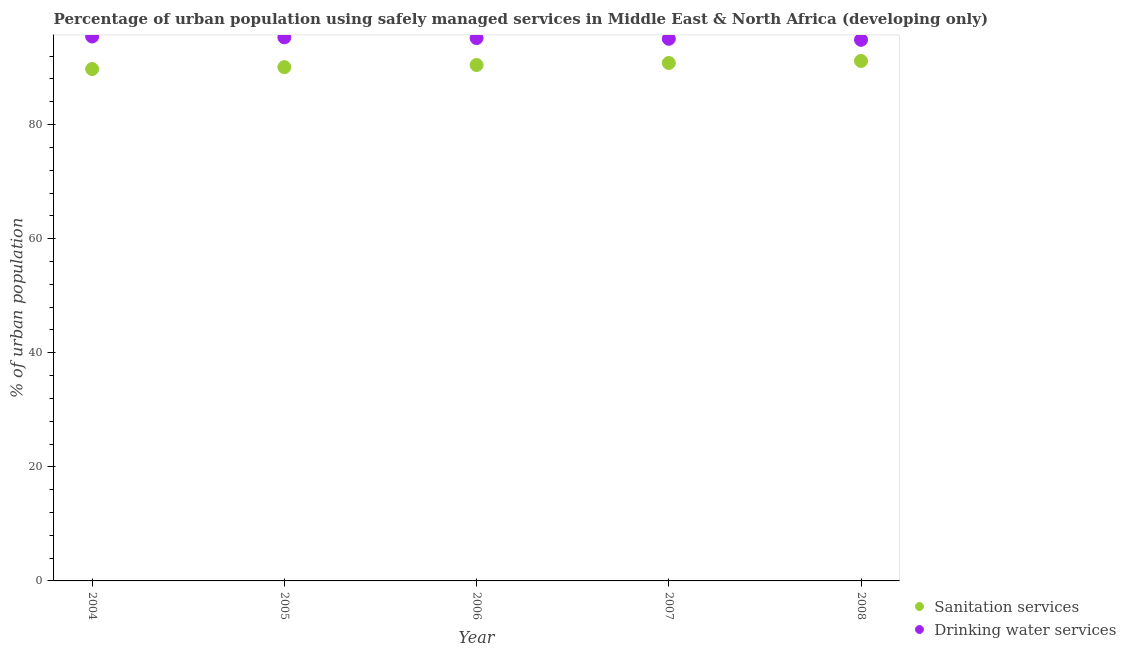Is the number of dotlines equal to the number of legend labels?
Your answer should be very brief. Yes. What is the percentage of urban population who used drinking water services in 2005?
Provide a succinct answer. 95.3. Across all years, what is the maximum percentage of urban population who used sanitation services?
Provide a succinct answer. 91.16. Across all years, what is the minimum percentage of urban population who used drinking water services?
Give a very brief answer. 94.87. In which year was the percentage of urban population who used sanitation services maximum?
Your response must be concise. 2008. In which year was the percentage of urban population who used sanitation services minimum?
Offer a very short reply. 2004. What is the total percentage of urban population who used sanitation services in the graph?
Your answer should be compact. 452.23. What is the difference between the percentage of urban population who used sanitation services in 2004 and that in 2007?
Offer a very short reply. -1.06. What is the difference between the percentage of urban population who used drinking water services in 2008 and the percentage of urban population who used sanitation services in 2004?
Provide a succinct answer. 5.12. What is the average percentage of urban population who used drinking water services per year?
Ensure brevity in your answer.  95.17. In the year 2005, what is the difference between the percentage of urban population who used sanitation services and percentage of urban population who used drinking water services?
Your answer should be very brief. -5.23. What is the ratio of the percentage of urban population who used drinking water services in 2005 to that in 2006?
Your answer should be very brief. 1. Is the percentage of urban population who used sanitation services in 2006 less than that in 2007?
Ensure brevity in your answer.  Yes. What is the difference between the highest and the second highest percentage of urban population who used drinking water services?
Offer a terse response. 0.15. What is the difference between the highest and the lowest percentage of urban population who used drinking water services?
Give a very brief answer. 0.58. Is the sum of the percentage of urban population who used drinking water services in 2004 and 2006 greater than the maximum percentage of urban population who used sanitation services across all years?
Your answer should be compact. Yes. Does the percentage of urban population who used sanitation services monotonically increase over the years?
Your answer should be very brief. Yes. Is the percentage of urban population who used drinking water services strictly less than the percentage of urban population who used sanitation services over the years?
Your answer should be compact. No. How many dotlines are there?
Your answer should be compact. 2. How many years are there in the graph?
Give a very brief answer. 5. What is the difference between two consecutive major ticks on the Y-axis?
Provide a succinct answer. 20. Are the values on the major ticks of Y-axis written in scientific E-notation?
Your answer should be very brief. No. Where does the legend appear in the graph?
Offer a terse response. Bottom right. What is the title of the graph?
Your answer should be very brief. Percentage of urban population using safely managed services in Middle East & North Africa (developing only). What is the label or title of the X-axis?
Ensure brevity in your answer.  Year. What is the label or title of the Y-axis?
Your answer should be very brief. % of urban population. What is the % of urban population of Sanitation services in 2004?
Make the answer very short. 89.74. What is the % of urban population of Drinking water services in 2004?
Your answer should be compact. 95.45. What is the % of urban population in Sanitation services in 2005?
Ensure brevity in your answer.  90.07. What is the % of urban population of Drinking water services in 2005?
Offer a very short reply. 95.3. What is the % of urban population of Sanitation services in 2006?
Make the answer very short. 90.45. What is the % of urban population in Drinking water services in 2006?
Offer a terse response. 95.17. What is the % of urban population in Sanitation services in 2007?
Ensure brevity in your answer.  90.81. What is the % of urban population in Drinking water services in 2007?
Offer a very short reply. 95.05. What is the % of urban population in Sanitation services in 2008?
Keep it short and to the point. 91.16. What is the % of urban population in Drinking water services in 2008?
Your answer should be very brief. 94.87. Across all years, what is the maximum % of urban population of Sanitation services?
Make the answer very short. 91.16. Across all years, what is the maximum % of urban population in Drinking water services?
Your answer should be compact. 95.45. Across all years, what is the minimum % of urban population of Sanitation services?
Offer a very short reply. 89.74. Across all years, what is the minimum % of urban population in Drinking water services?
Provide a short and direct response. 94.87. What is the total % of urban population of Sanitation services in the graph?
Your response must be concise. 452.23. What is the total % of urban population of Drinking water services in the graph?
Ensure brevity in your answer.  475.84. What is the difference between the % of urban population in Sanitation services in 2004 and that in 2005?
Your answer should be compact. -0.33. What is the difference between the % of urban population in Drinking water services in 2004 and that in 2005?
Your response must be concise. 0.15. What is the difference between the % of urban population in Sanitation services in 2004 and that in 2006?
Offer a very short reply. -0.71. What is the difference between the % of urban population in Drinking water services in 2004 and that in 2006?
Keep it short and to the point. 0.28. What is the difference between the % of urban population of Sanitation services in 2004 and that in 2007?
Give a very brief answer. -1.06. What is the difference between the % of urban population of Drinking water services in 2004 and that in 2007?
Provide a succinct answer. 0.4. What is the difference between the % of urban population in Sanitation services in 2004 and that in 2008?
Provide a short and direct response. -1.42. What is the difference between the % of urban population in Drinking water services in 2004 and that in 2008?
Your answer should be very brief. 0.58. What is the difference between the % of urban population in Sanitation services in 2005 and that in 2006?
Your answer should be very brief. -0.38. What is the difference between the % of urban population in Drinking water services in 2005 and that in 2006?
Your answer should be compact. 0.13. What is the difference between the % of urban population of Sanitation services in 2005 and that in 2007?
Offer a terse response. -0.73. What is the difference between the % of urban population of Drinking water services in 2005 and that in 2007?
Your response must be concise. 0.25. What is the difference between the % of urban population in Sanitation services in 2005 and that in 2008?
Offer a terse response. -1.09. What is the difference between the % of urban population of Drinking water services in 2005 and that in 2008?
Make the answer very short. 0.43. What is the difference between the % of urban population of Sanitation services in 2006 and that in 2007?
Ensure brevity in your answer.  -0.36. What is the difference between the % of urban population in Drinking water services in 2006 and that in 2007?
Your response must be concise. 0.12. What is the difference between the % of urban population of Sanitation services in 2006 and that in 2008?
Give a very brief answer. -0.71. What is the difference between the % of urban population in Drinking water services in 2006 and that in 2008?
Offer a terse response. 0.31. What is the difference between the % of urban population of Sanitation services in 2007 and that in 2008?
Give a very brief answer. -0.36. What is the difference between the % of urban population of Drinking water services in 2007 and that in 2008?
Offer a very short reply. 0.18. What is the difference between the % of urban population in Sanitation services in 2004 and the % of urban population in Drinking water services in 2005?
Ensure brevity in your answer.  -5.56. What is the difference between the % of urban population of Sanitation services in 2004 and the % of urban population of Drinking water services in 2006?
Your answer should be compact. -5.43. What is the difference between the % of urban population in Sanitation services in 2004 and the % of urban population in Drinking water services in 2007?
Your answer should be very brief. -5.31. What is the difference between the % of urban population of Sanitation services in 2004 and the % of urban population of Drinking water services in 2008?
Your response must be concise. -5.12. What is the difference between the % of urban population in Sanitation services in 2005 and the % of urban population in Drinking water services in 2006?
Offer a very short reply. -5.1. What is the difference between the % of urban population in Sanitation services in 2005 and the % of urban population in Drinking water services in 2007?
Keep it short and to the point. -4.97. What is the difference between the % of urban population of Sanitation services in 2005 and the % of urban population of Drinking water services in 2008?
Your answer should be very brief. -4.79. What is the difference between the % of urban population in Sanitation services in 2006 and the % of urban population in Drinking water services in 2007?
Your answer should be compact. -4.6. What is the difference between the % of urban population in Sanitation services in 2006 and the % of urban population in Drinking water services in 2008?
Your answer should be very brief. -4.42. What is the difference between the % of urban population of Sanitation services in 2007 and the % of urban population of Drinking water services in 2008?
Offer a terse response. -4.06. What is the average % of urban population of Sanitation services per year?
Offer a terse response. 90.45. What is the average % of urban population in Drinking water services per year?
Your answer should be very brief. 95.17. In the year 2004, what is the difference between the % of urban population in Sanitation services and % of urban population in Drinking water services?
Your response must be concise. -5.71. In the year 2005, what is the difference between the % of urban population of Sanitation services and % of urban population of Drinking water services?
Give a very brief answer. -5.23. In the year 2006, what is the difference between the % of urban population in Sanitation services and % of urban population in Drinking water services?
Your answer should be very brief. -4.72. In the year 2007, what is the difference between the % of urban population of Sanitation services and % of urban population of Drinking water services?
Your answer should be compact. -4.24. In the year 2008, what is the difference between the % of urban population of Sanitation services and % of urban population of Drinking water services?
Offer a very short reply. -3.71. What is the ratio of the % of urban population in Sanitation services in 2004 to that in 2006?
Ensure brevity in your answer.  0.99. What is the ratio of the % of urban population in Drinking water services in 2004 to that in 2006?
Your response must be concise. 1. What is the ratio of the % of urban population in Sanitation services in 2004 to that in 2007?
Give a very brief answer. 0.99. What is the ratio of the % of urban population of Sanitation services in 2004 to that in 2008?
Provide a succinct answer. 0.98. What is the ratio of the % of urban population in Drinking water services in 2005 to that in 2006?
Provide a succinct answer. 1. What is the ratio of the % of urban population in Sanitation services in 2005 to that in 2007?
Provide a short and direct response. 0.99. What is the ratio of the % of urban population in Drinking water services in 2005 to that in 2007?
Offer a terse response. 1. What is the ratio of the % of urban population in Sanitation services in 2005 to that in 2008?
Offer a very short reply. 0.99. What is the ratio of the % of urban population in Drinking water services in 2007 to that in 2008?
Offer a terse response. 1. What is the difference between the highest and the second highest % of urban population of Sanitation services?
Ensure brevity in your answer.  0.36. What is the difference between the highest and the second highest % of urban population in Drinking water services?
Provide a short and direct response. 0.15. What is the difference between the highest and the lowest % of urban population of Sanitation services?
Offer a terse response. 1.42. What is the difference between the highest and the lowest % of urban population in Drinking water services?
Offer a very short reply. 0.58. 